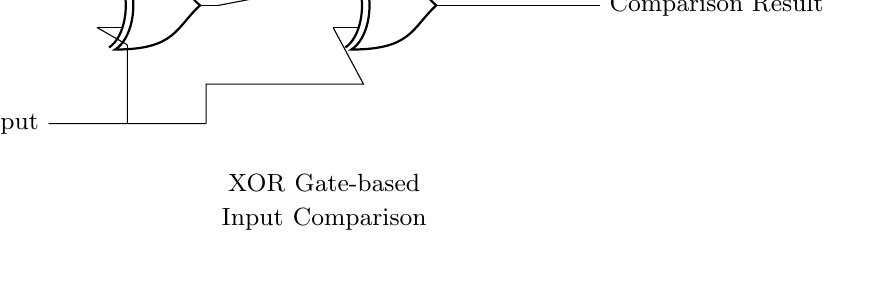What are the inputs to the first XOR gate? The first XOR gate receives input from Player 1 and Player 2. These inputs are represented in the circuit as lines leading into the gate from the respective players.
Answer: Player 1 and Player 2 What is the output of the first XOR gate? The output of the first XOR gate can be identified as the line that comes out of the gate and is subsequently connected to the second XOR gate.
Answer: Comparison Result How many XOR gates are present in the circuit? The circuit contains two XOR gates, as can be seen by counting the XOR symbols drawn in the diagram.
Answer: Two What is the purpose of the second XOR gate? The second XOR gate takes the output from the first XOR gate and compares it with both Player 1 and Player 2 inputs, outputting a final comparison result. This provides a final decision on whether the inputs are the same or different.
Answer: Compare inputs How is the connection made between the first and second XOR gates? The connection from the first XOR gate to the second XOR gate is made through a wire that leads from the output of the first gate to an input of the second gate, indicating a direct line of communication between the two.
Answer: Direct wire connection What occurs when Player 1 and Player 2 inputs are the same? When the inputs from Player 1 and Player 2 are the same, the output of the XOR gates will be low (or false/0), as XOR gates output high only when their inputs differ.
Answer: Output is low 